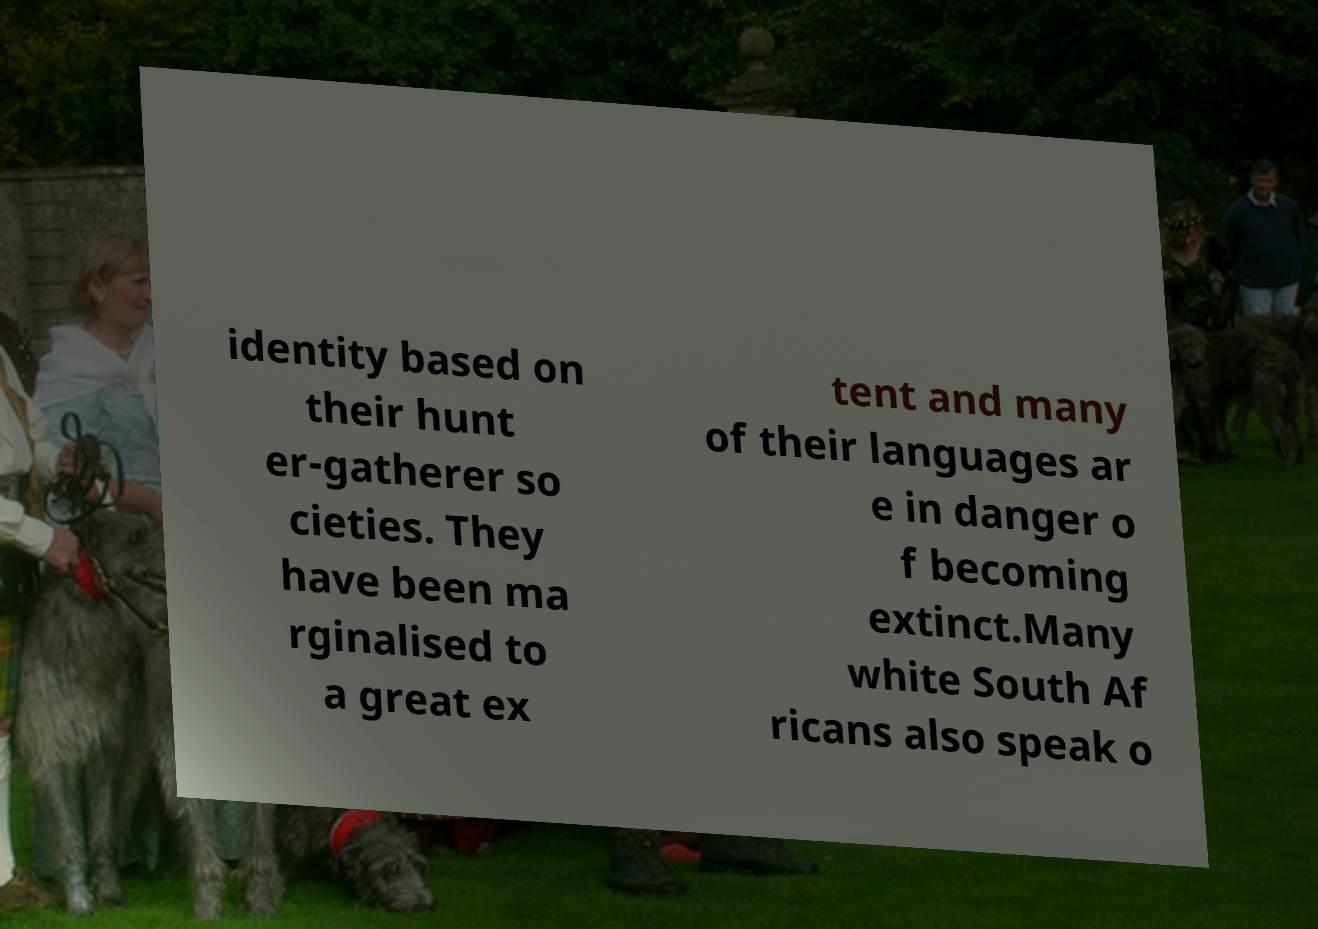What messages or text are displayed in this image? I need them in a readable, typed format. identity based on their hunt er-gatherer so cieties. They have been ma rginalised to a great ex tent and many of their languages ar e in danger o f becoming extinct.Many white South Af ricans also speak o 